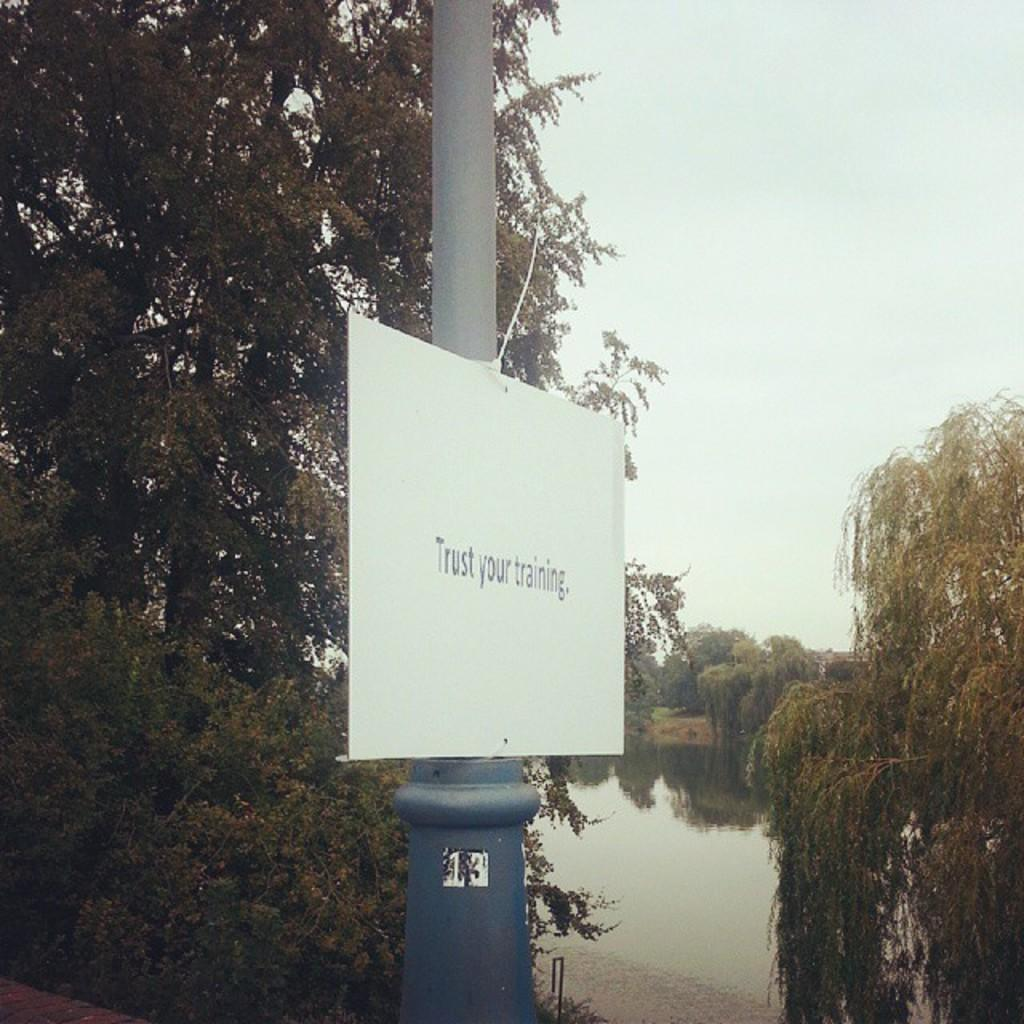What is the main object in the image? There is a pole in the image. What is attached to the pole? There is a board on the pole. What can be seen in the background of the image? There is a lake and trees in the background of the image. How is the sky depicted in the image? The sky is clear in the image. How many legs does the pole have in the image? The pole does not have legs; it is a single, vertical structure. What type of muscle is being exercised by the pole in the image? The pole is not a muscle and does not exercise any muscles; it is an inanimate object. 